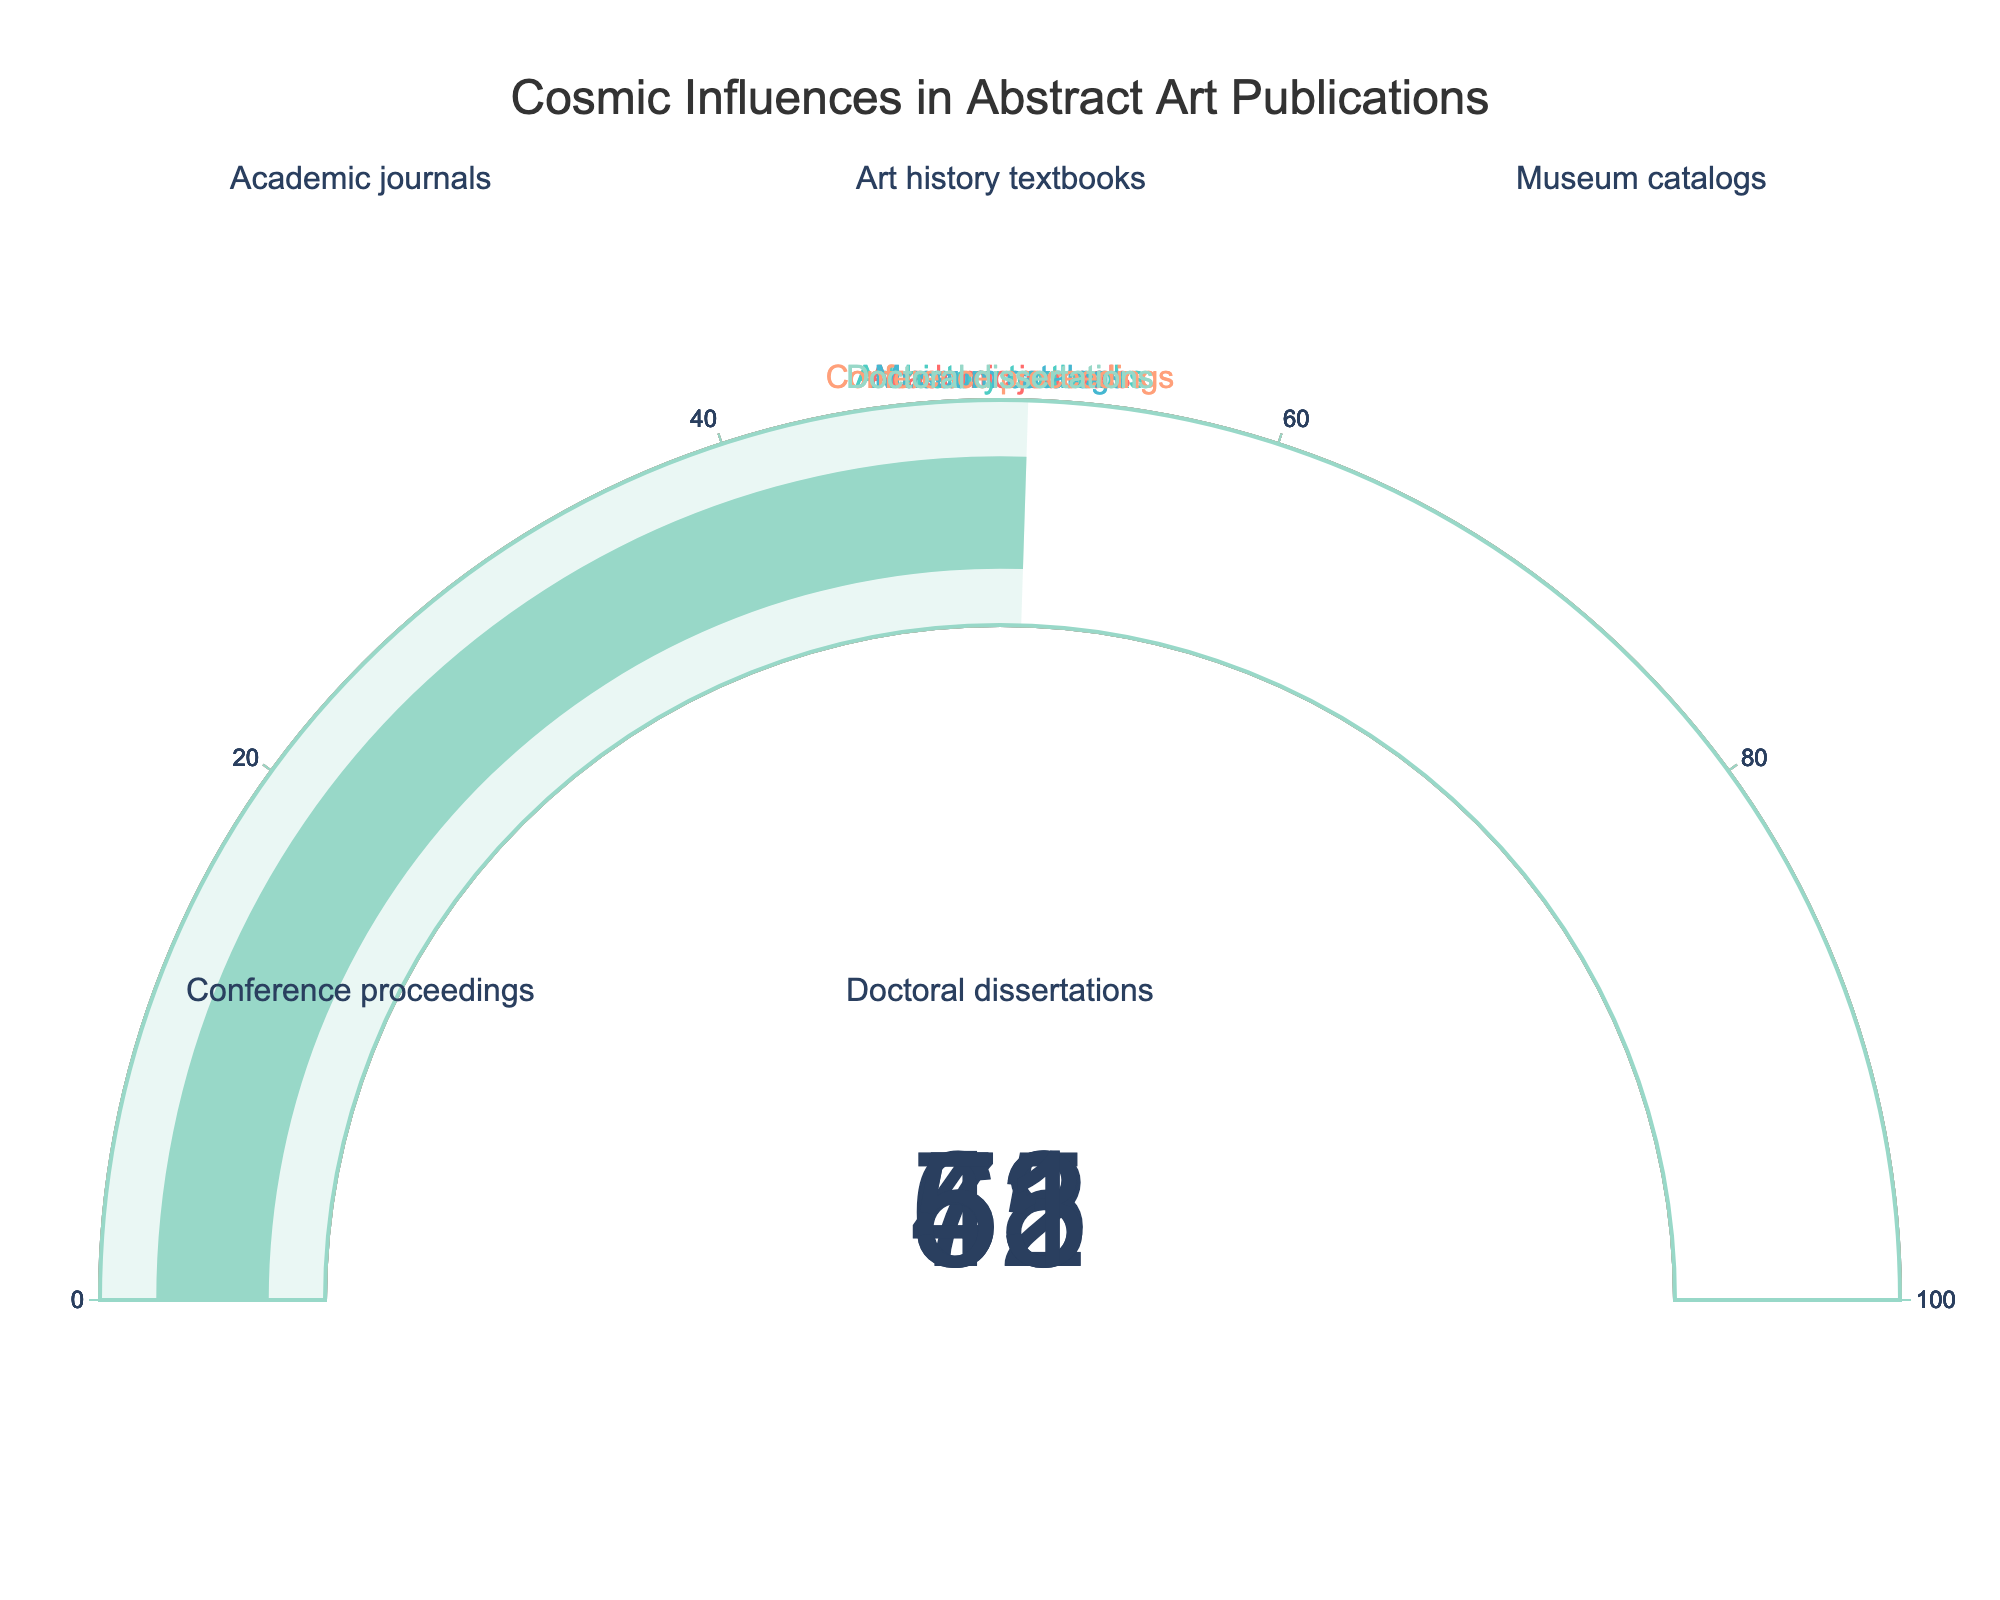What's the highest percentage shown on the gauge charts? In the figure, you can observe that each gauge shows a percentage. The highest percentage displayed is on the gauge representing "Academic journals".
Answer: 72% Which publication type has the lowest percentage of mentions of cosmic influences? By examining all the gauge charts, the gauge displaying the percentage for "Museum catalogs" represents the lowest value.
Answer: Museum catalogs What's the total percentage when combining Conference proceedings and Doctoral dissertations? Adding the percentages displayed on the gauges for Conference proceedings (63) and Doctoral dissertations (51) gives us 63 + 51 = 114.
Answer: 114 How many publication types are displayed in the figure? The figure shows five gauges, each representing a different publication type: Academic journals, Art history textbooks, Museum catalogs, Conference proceedings, and Doctoral dissertations.
Answer: 5 What is the average percentage of mentions of cosmic influences across all publication types shown? To find the average, sum all the percentages: 72 (Academic journals) + 58 (Art history textbooks) + 45 (Museum catalogs) + 63 (Conference proceedings) + 51 (Doctoral dissertations) = 289. Divide by the number of publication types (5): 289 / 5 = 57.8.
Answer: 57.8 Are there any publication types with a percentage greater than 70%? Look at each gauge's percentage: only "Academic journals" has a percentage greater than 70%.
Answer: Yes Compare the percentages of Academic journals and Art history textbooks. Which one is higher? The gauge for Academic journals shows 72%, while the gauge for Art history textbooks shows 58%. Thus, Academic journals has a higher percentage.
Answer: Academic journals What is the difference between the highest and lowest percentage values in the figure? The highest percentage is 72% (Academic journals) and the lowest is 45% (Museum catalogs). Subtract the lowest from the highest: 72 - 45 = 27.
Answer: 27 What is the median percentage of mentions among all the publication types? The percentages are: 72, 58, 45, 63, and 51. Arranging them in ascending order: 45, 51, 58, 63, 72. The median value, being the middle one, is 58.
Answer: 58 